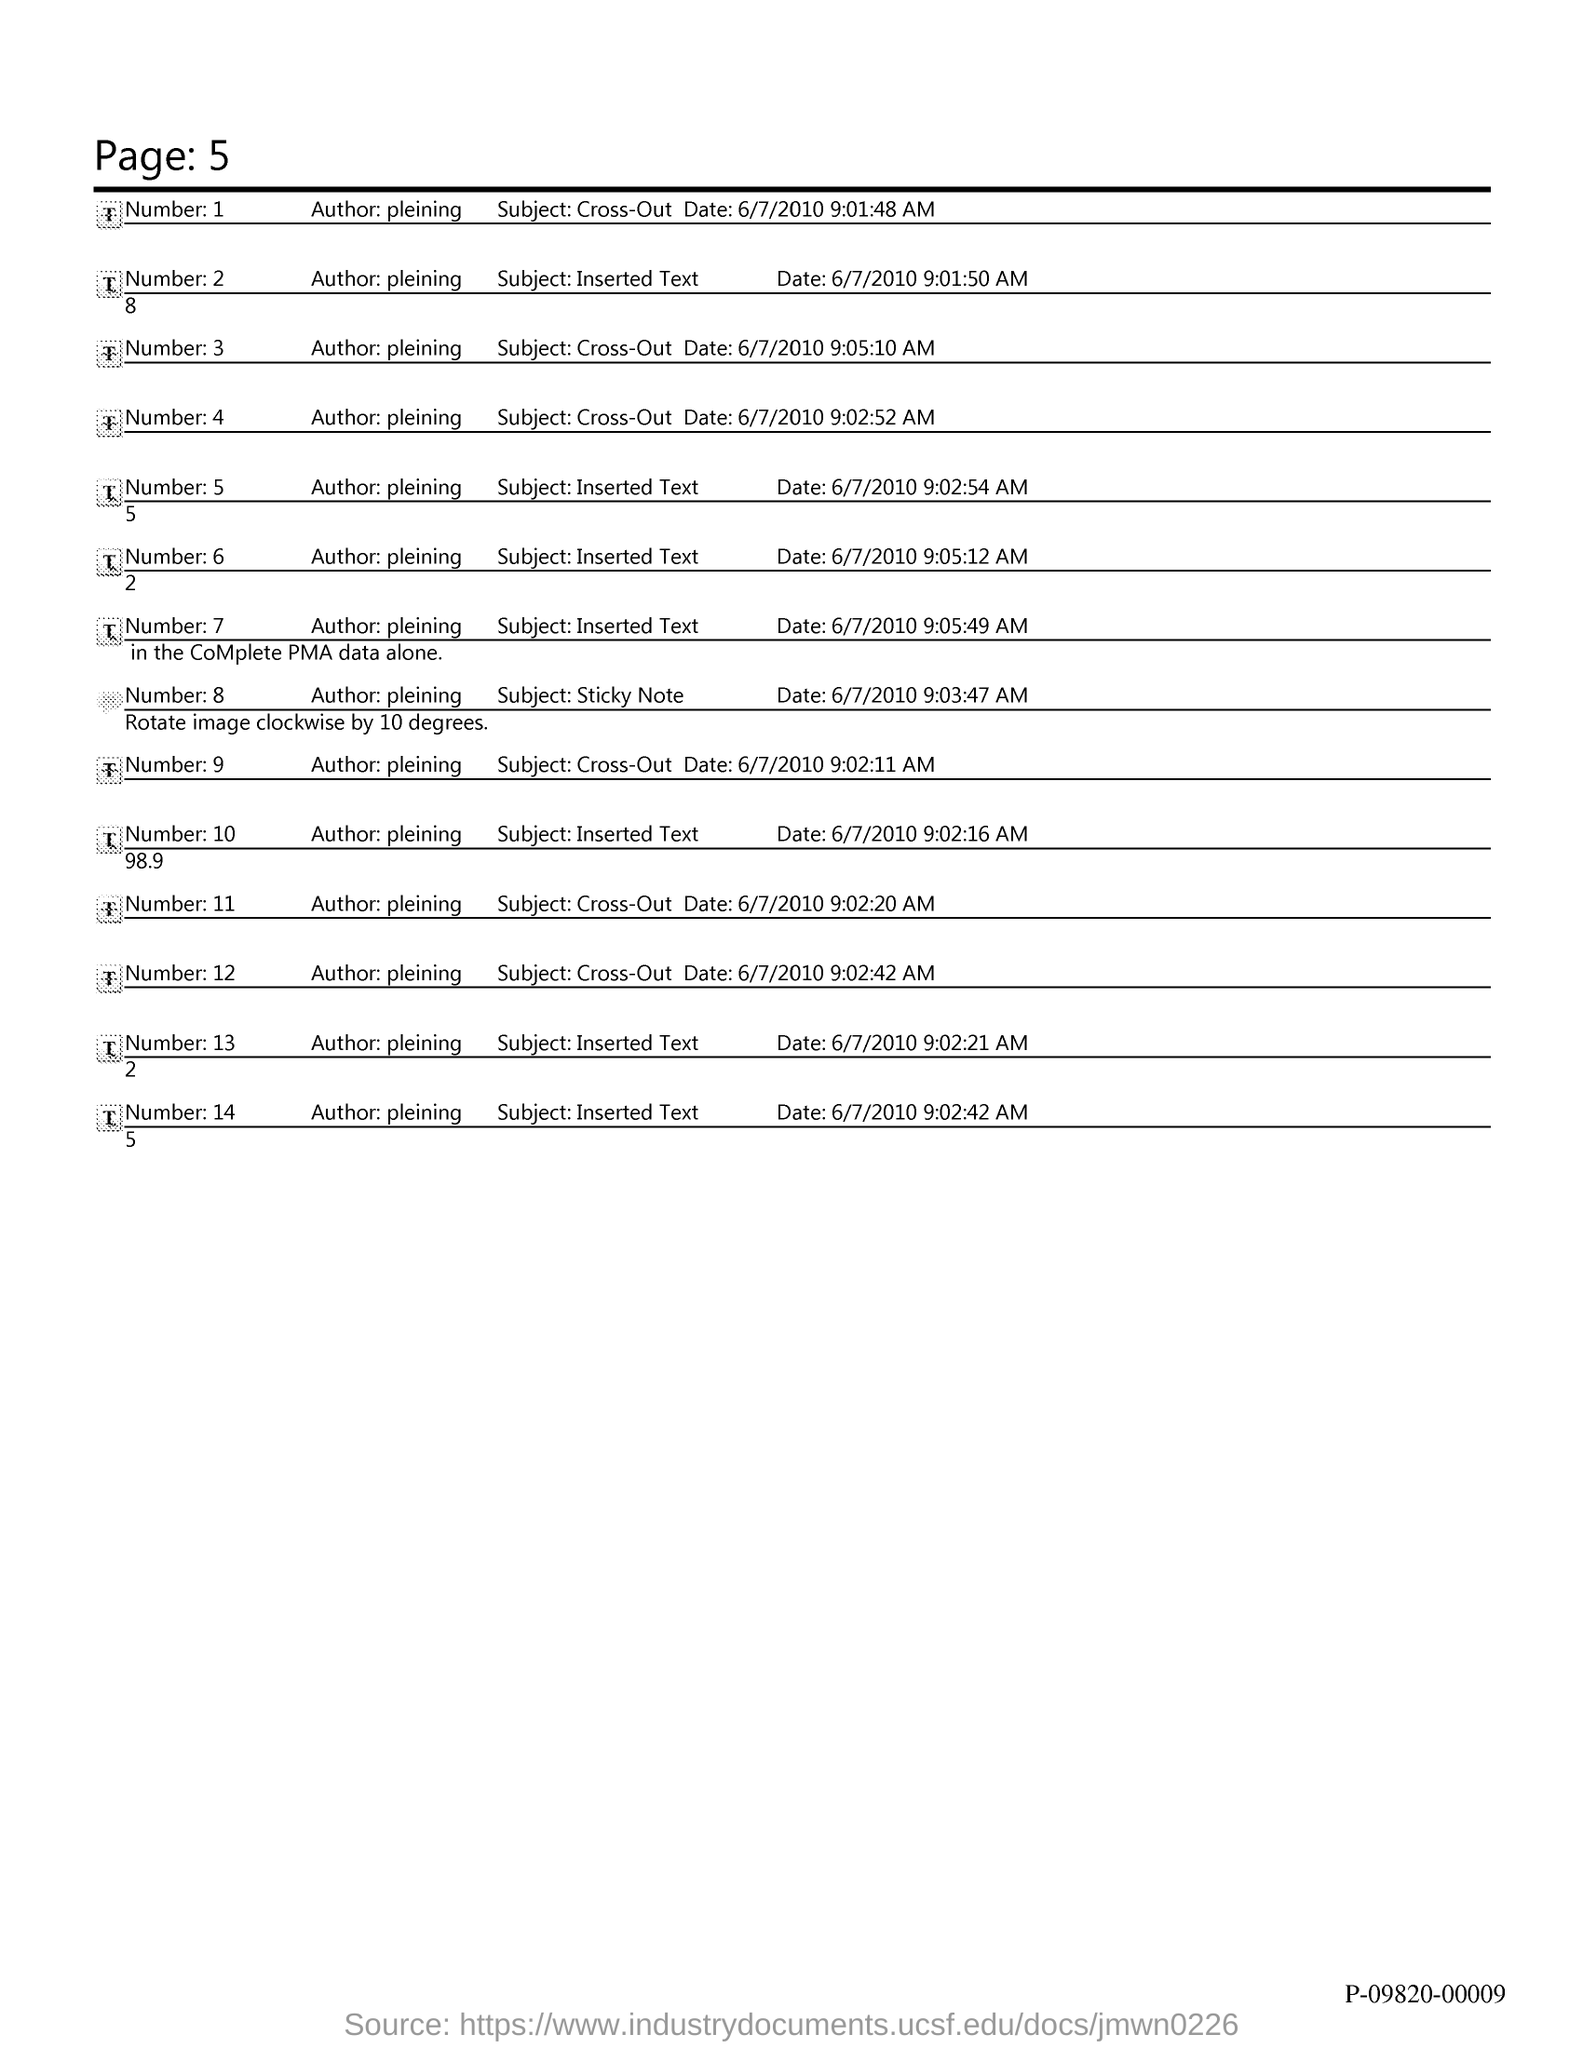What is the Page Number?
Your answer should be very brief. 5. 